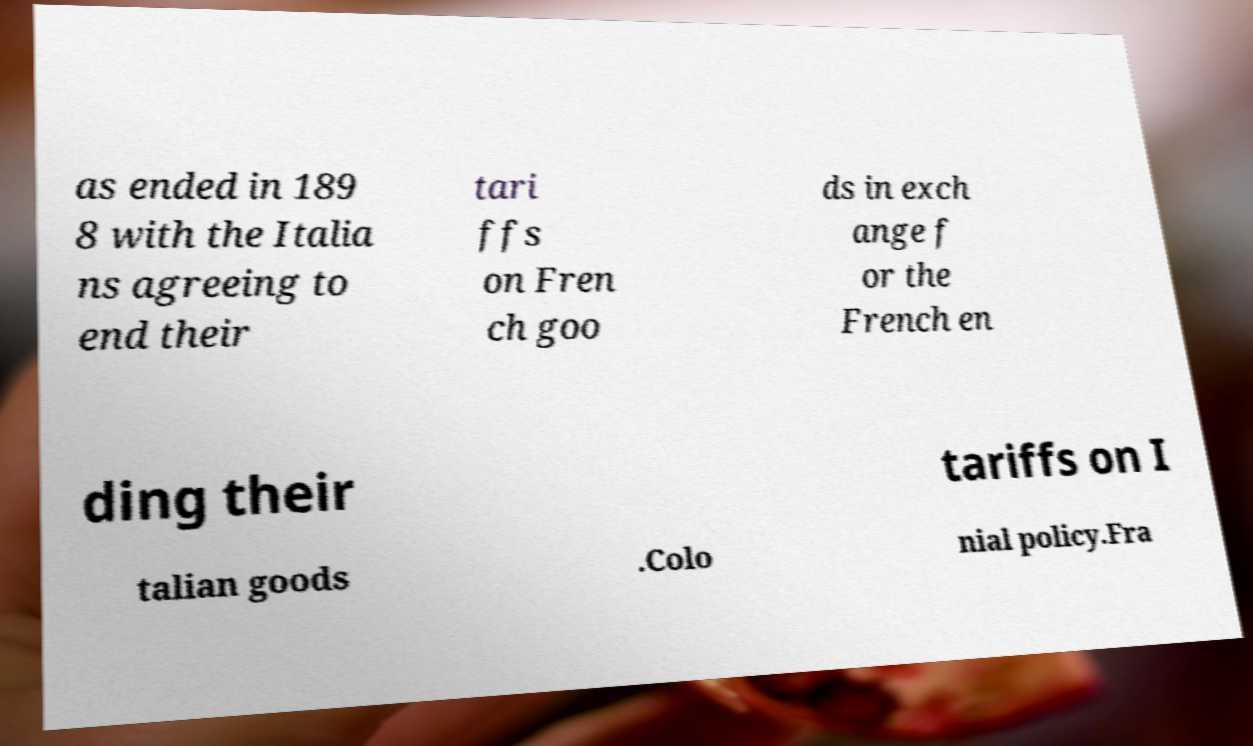Please read and relay the text visible in this image. What does it say? as ended in 189 8 with the Italia ns agreeing to end their tari ffs on Fren ch goo ds in exch ange f or the French en ding their tariffs on I talian goods .Colo nial policy.Fra 